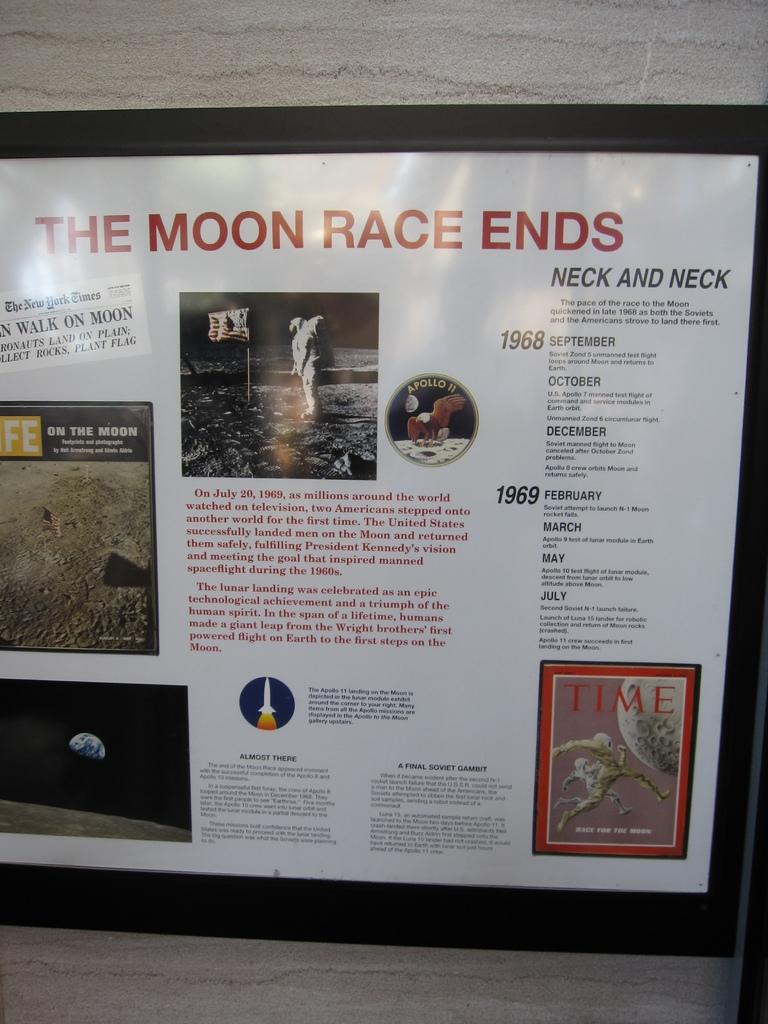What year did the moon race end in?
Give a very brief answer. 1969. 